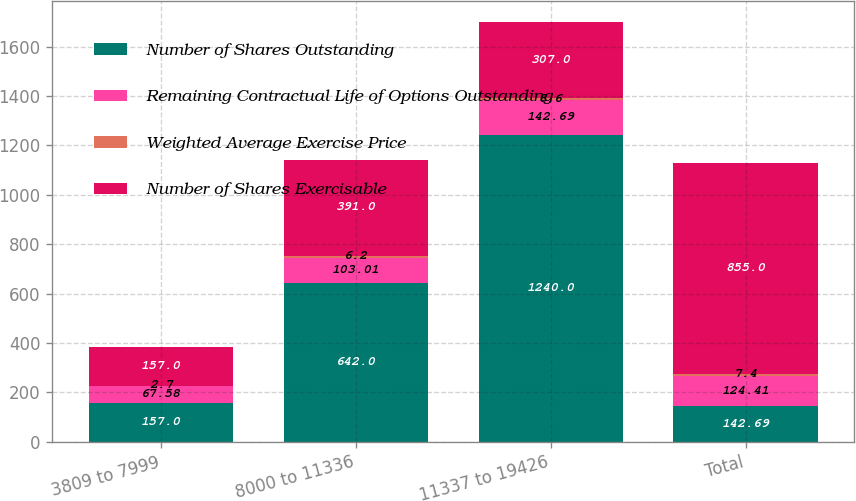Convert chart to OTSL. <chart><loc_0><loc_0><loc_500><loc_500><stacked_bar_chart><ecel><fcel>3809 to 7999<fcel>8000 to 11336<fcel>11337 to 19426<fcel>Total<nl><fcel>Number of Shares Outstanding<fcel>157<fcel>642<fcel>1240<fcel>142.69<nl><fcel>Remaining Contractual Life of Options Outstanding<fcel>67.58<fcel>103.01<fcel>142.69<fcel>124.41<nl><fcel>Weighted Average Exercise Price<fcel>2.7<fcel>6.2<fcel>8.6<fcel>7.4<nl><fcel>Number of Shares Exercisable<fcel>157<fcel>391<fcel>307<fcel>855<nl></chart> 